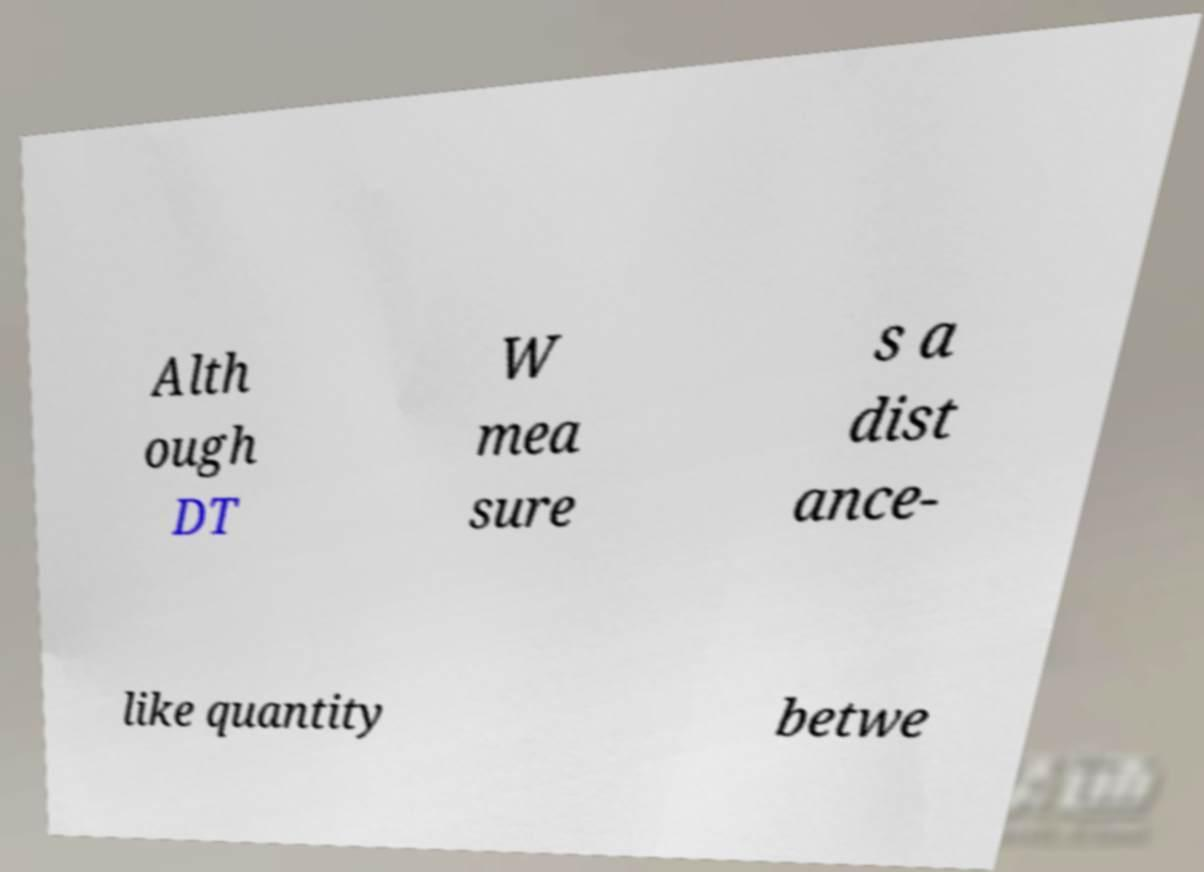Could you assist in decoding the text presented in this image and type it out clearly? Alth ough DT W mea sure s a dist ance- like quantity betwe 